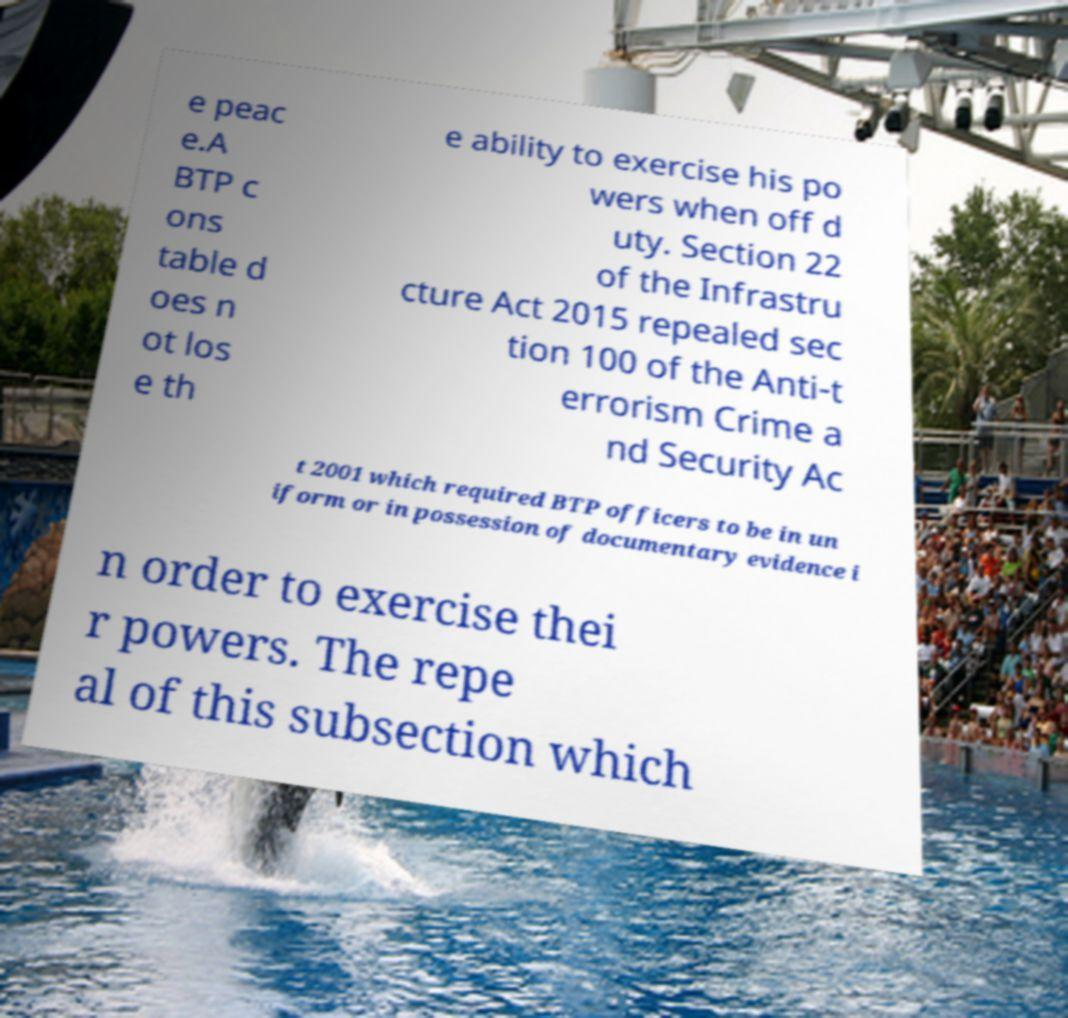Please identify and transcribe the text found in this image. e peac e.A BTP c ons table d oes n ot los e th e ability to exercise his po wers when off d uty. Section 22 of the Infrastru cture Act 2015 repealed sec tion 100 of the Anti-t errorism Crime a nd Security Ac t 2001 which required BTP officers to be in un iform or in possession of documentary evidence i n order to exercise thei r powers. The repe al of this subsection which 